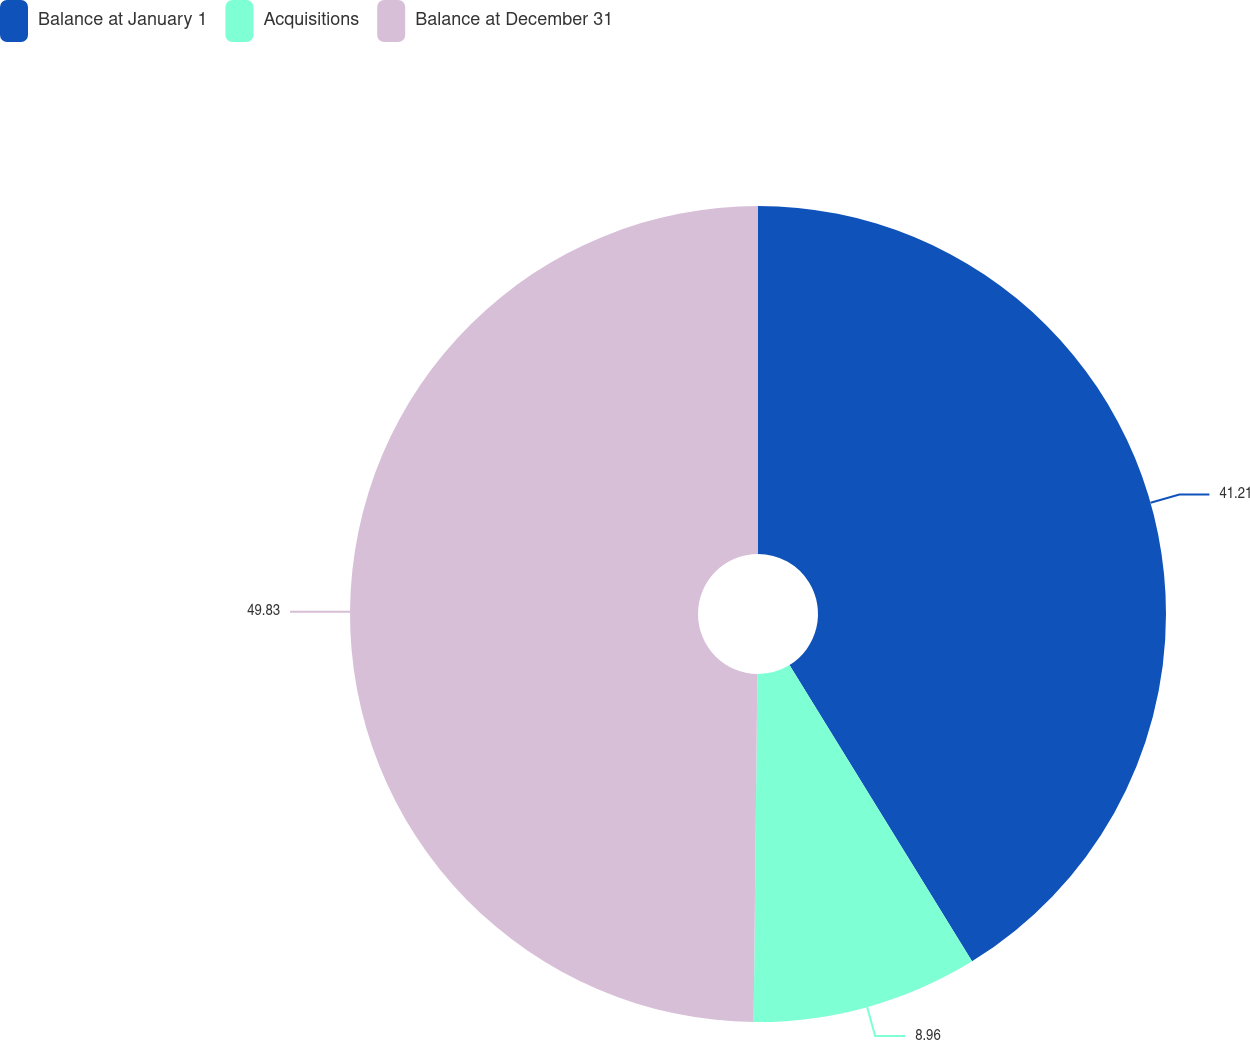Convert chart. <chart><loc_0><loc_0><loc_500><loc_500><pie_chart><fcel>Balance at January 1<fcel>Acquisitions<fcel>Balance at December 31<nl><fcel>41.21%<fcel>8.96%<fcel>49.83%<nl></chart> 